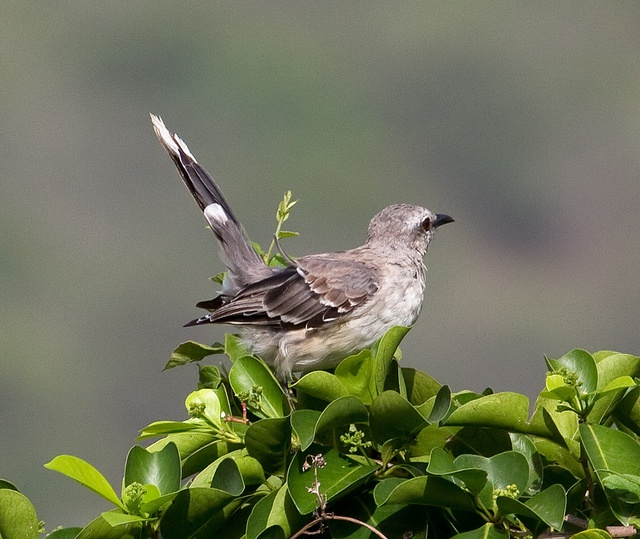Describe the objects in this image and their specific colors. I can see a bird in gray, darkgray, lightgray, and black tones in this image. 